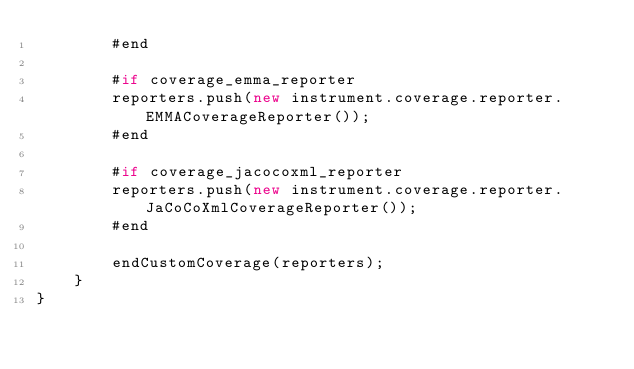Convert code to text. <code><loc_0><loc_0><loc_500><loc_500><_Haxe_>		#end

		#if coverage_emma_reporter
		reporters.push(new instrument.coverage.reporter.EMMACoverageReporter());
		#end

		#if coverage_jacocoxml_reporter
		reporters.push(new instrument.coverage.reporter.JaCoCoXmlCoverageReporter());
		#end

		endCustomCoverage(reporters);
	}
}
</code> 